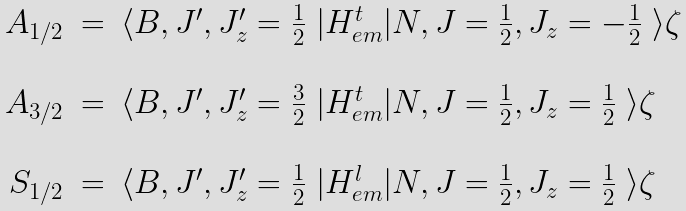Convert formula to latex. <formula><loc_0><loc_0><loc_500><loc_500>\begin{array} { r c l } A _ { 1 / 2 } & = & \langle B , J ^ { \prime } , J ^ { \prime } _ { z } = \frac { 1 } { 2 } \ | H _ { e m } ^ { t } | N , J = \frac { 1 } { 2 } , J _ { z } = - \frac { 1 } { 2 } \ \rangle \zeta \\ & & \\ A _ { 3 / 2 } & = & \langle B , J ^ { \prime } , J ^ { \prime } _ { z } = \frac { 3 } { 2 } \ | H _ { e m } ^ { t } | N , J = \frac { 1 } { 2 } , J _ { z } = \frac { 1 } { 2 } \ \rangle \zeta \\ & & \\ S _ { 1 / 2 } & = & \langle B , J ^ { \prime } , J ^ { \prime } _ { z } = \frac { 1 } { 2 } \ | H _ { e m } ^ { l } | N , J = \frac { 1 } { 2 } , J _ { z } = \frac { 1 } { 2 } \ \rangle \zeta \\ \end{array}</formula> 